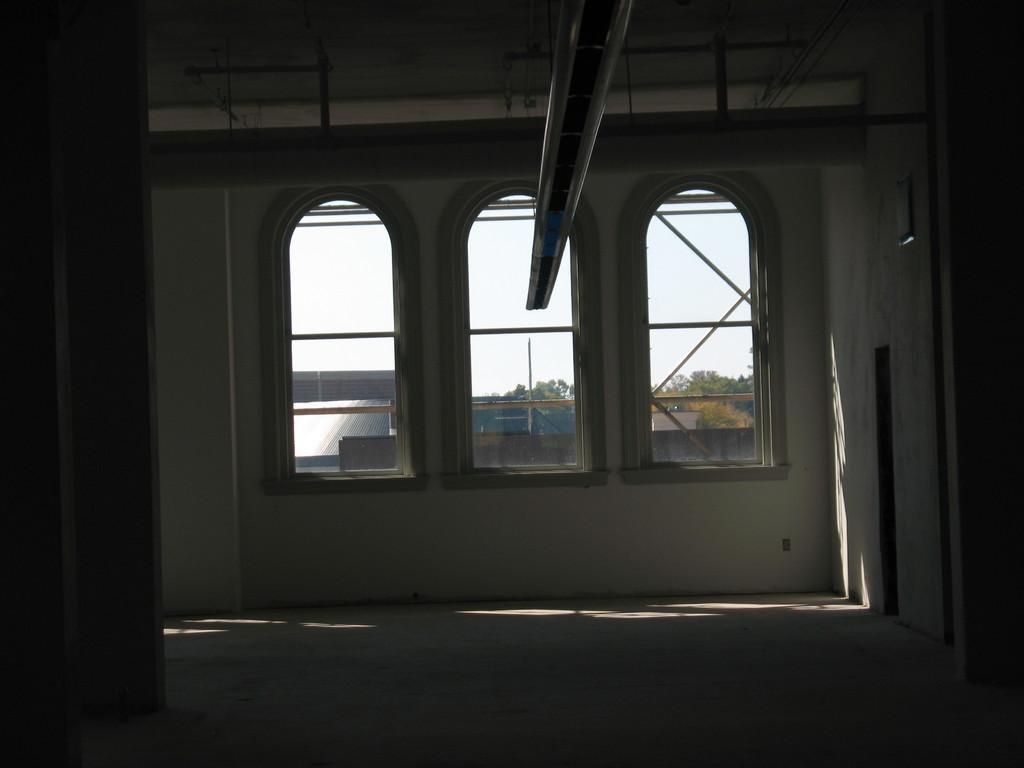How would you summarize this image in a sentence or two? This is an inside view of a building and here we can see windows, through the glass we can see poles and there are trees and buildings. 